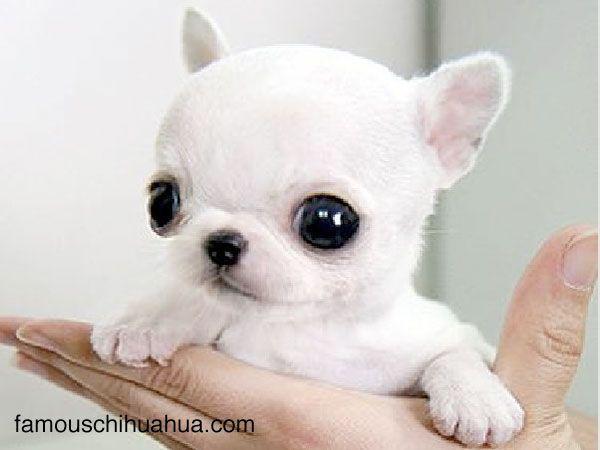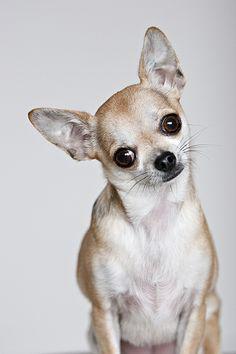The first image is the image on the left, the second image is the image on the right. Considering the images on both sides, is "A person's hand is shown in one of the images." valid? Answer yes or no. Yes. 